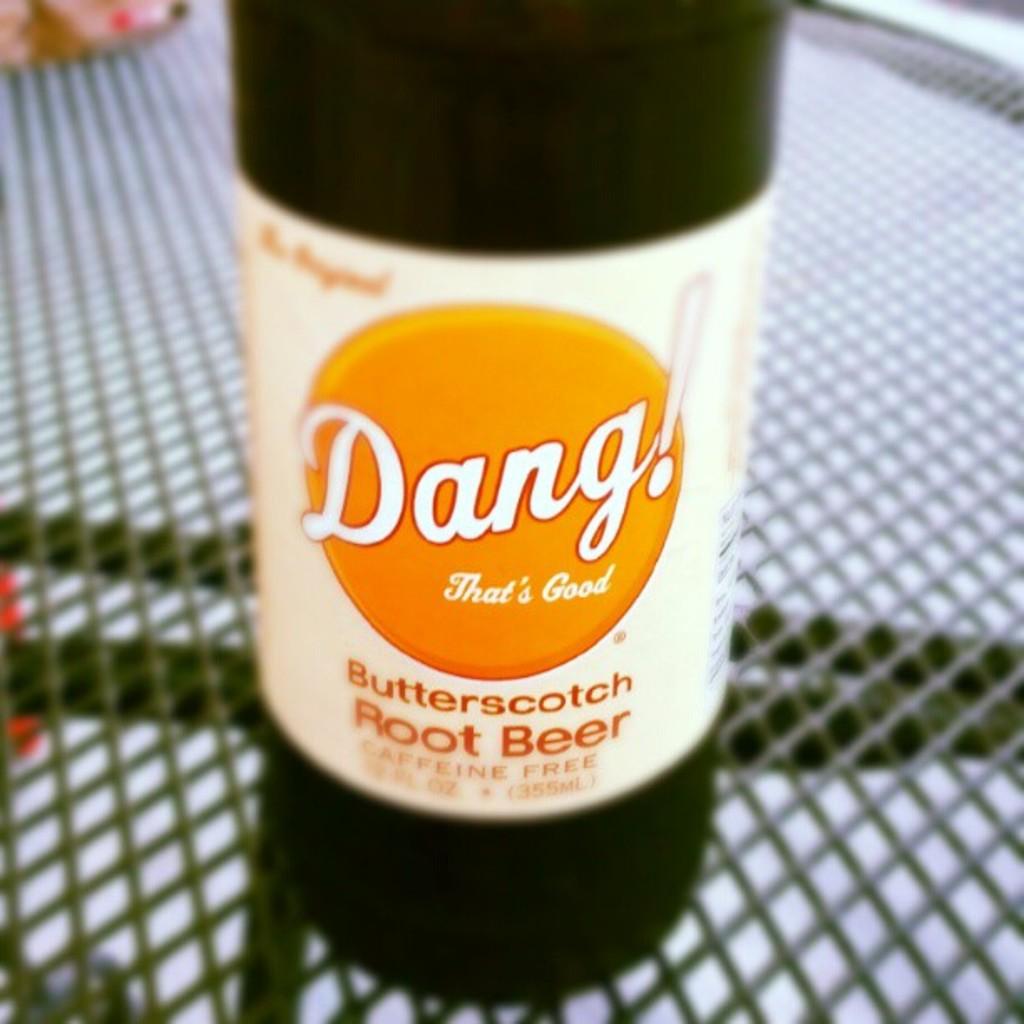What flavor is the rootbeer?
Make the answer very short. Butterscotch. 